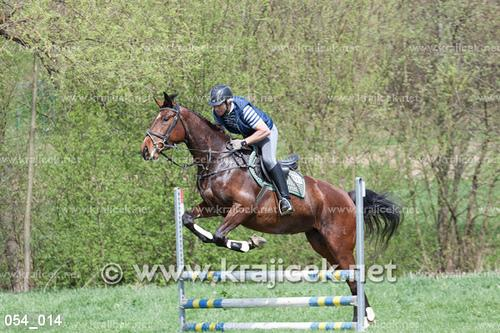Provide a brief description of the primary action occurring in the image. A man wearing a helmet and riding a red horse is jumping over a hurdle with blue and yellow stripes. In a few words, explain the main focus of the image. Horse and rider jumping an obstacle. Provide an artistic interpretation of the image, including the main subject and their action. A harmonious duo, man and steed elegantly dance midair, conquering vibrant obstacles with grace and precision. Mention the most significant event in the picture and the main participant. The main event is a horse and its rider jumping over a colorful obstacle, showcasing their skills. What is the central theme of this image? Include the main subject and their activity. The central theme of this image is equestrian sports, with a man riding a horse as they leap over a hurdle. Describe the primary action taking place in the image using passive voice. A hurdle with blue and yellow stripes is being jumped by a man on a red horse. Express the main event in the image with an exclamatory sentence. Wow, a man on a red horse is soaring high while jumping over a brilliantly striped hurdle! Write a short narrative describing the main subject and their action in the image. In this captivating moment, a skilled rider atop a majestic red horse gracefully jumps over a striped hurdle, displaying their talent and teamwork. What is happening in the picture? Use informal language to describe the scene. A dude in a helmet is riding a dope red horse, and they're both leaping over this wicked colorful hurdle together. Describe the key event in the image using simple and concise language. A man is riding a horse while jumping over a striped fence. 